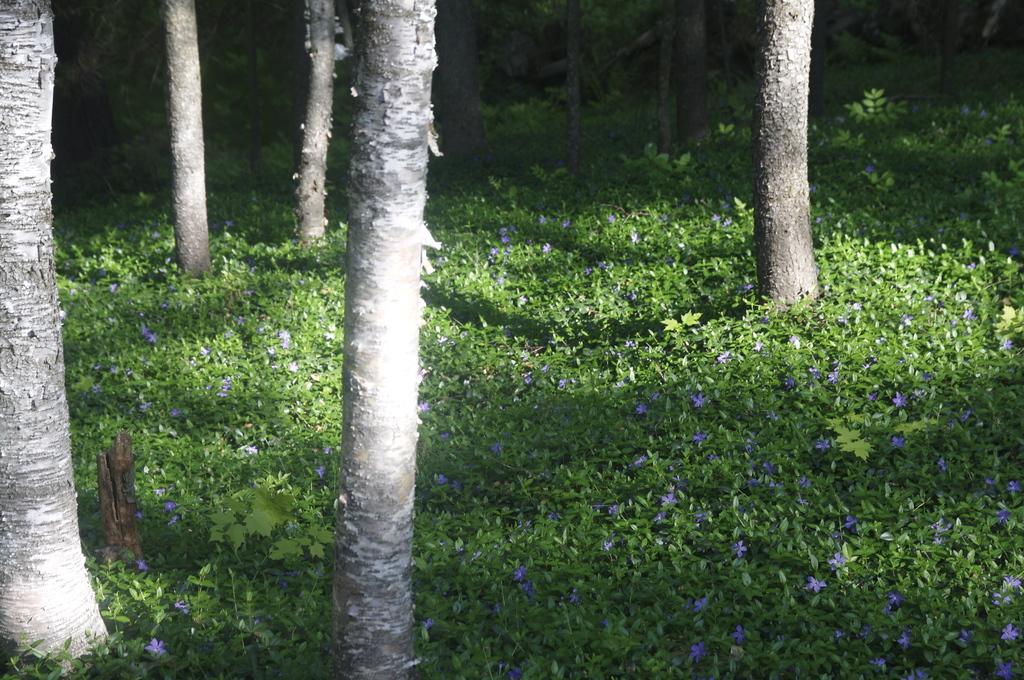In one or two sentences, can you explain what this image depicts? In this image we can see many trunks of the trees. There are many plants in the image. There are many flowers to the plants. 